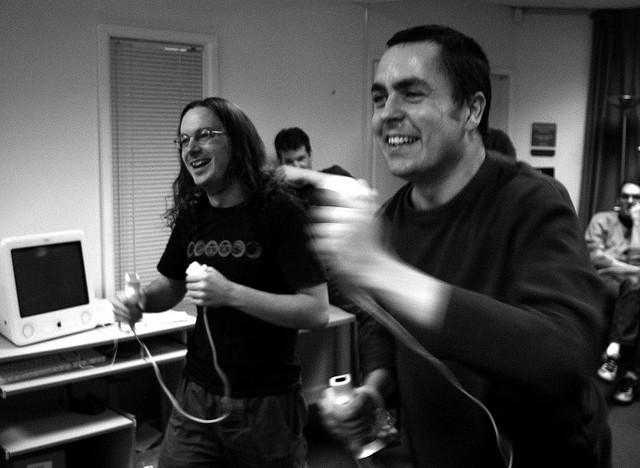What should be installed on the device with a screen? Please explain your reasoning. operating system. An os should be installed. 